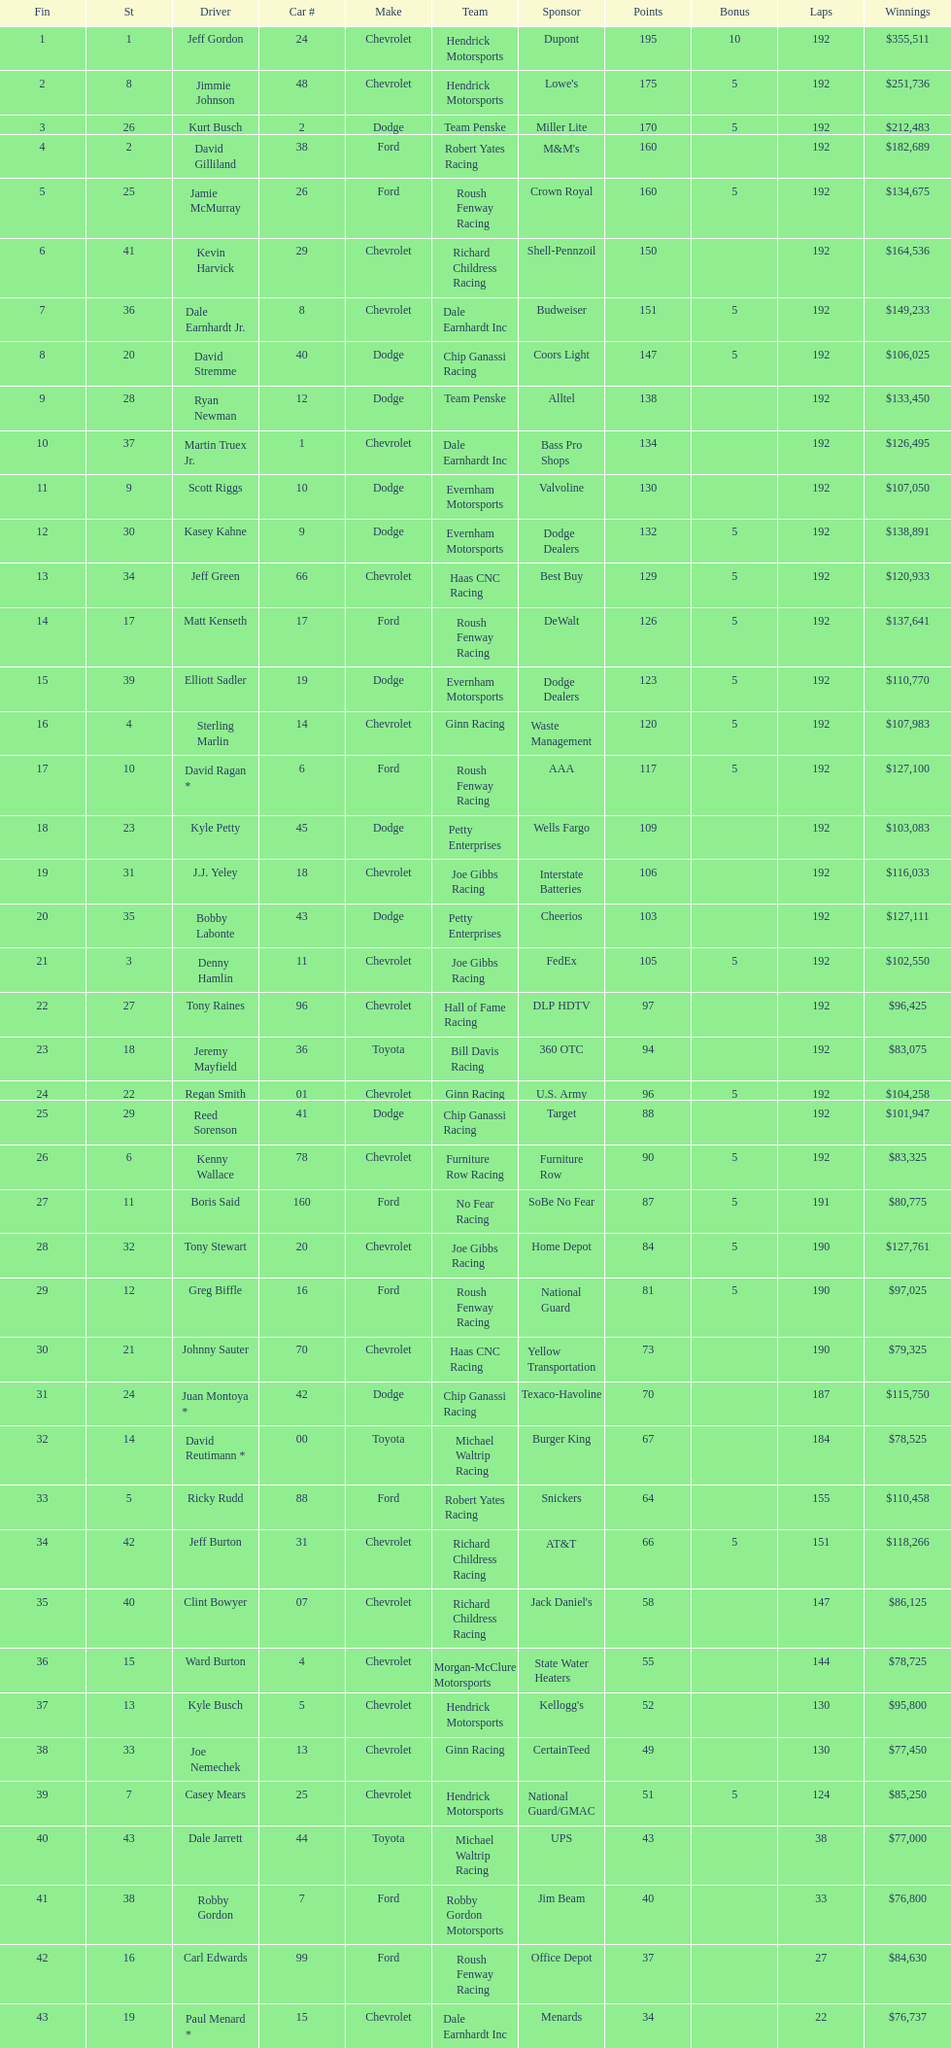Which make had the most consecutive finishes at the aarons 499? Chevrolet. 